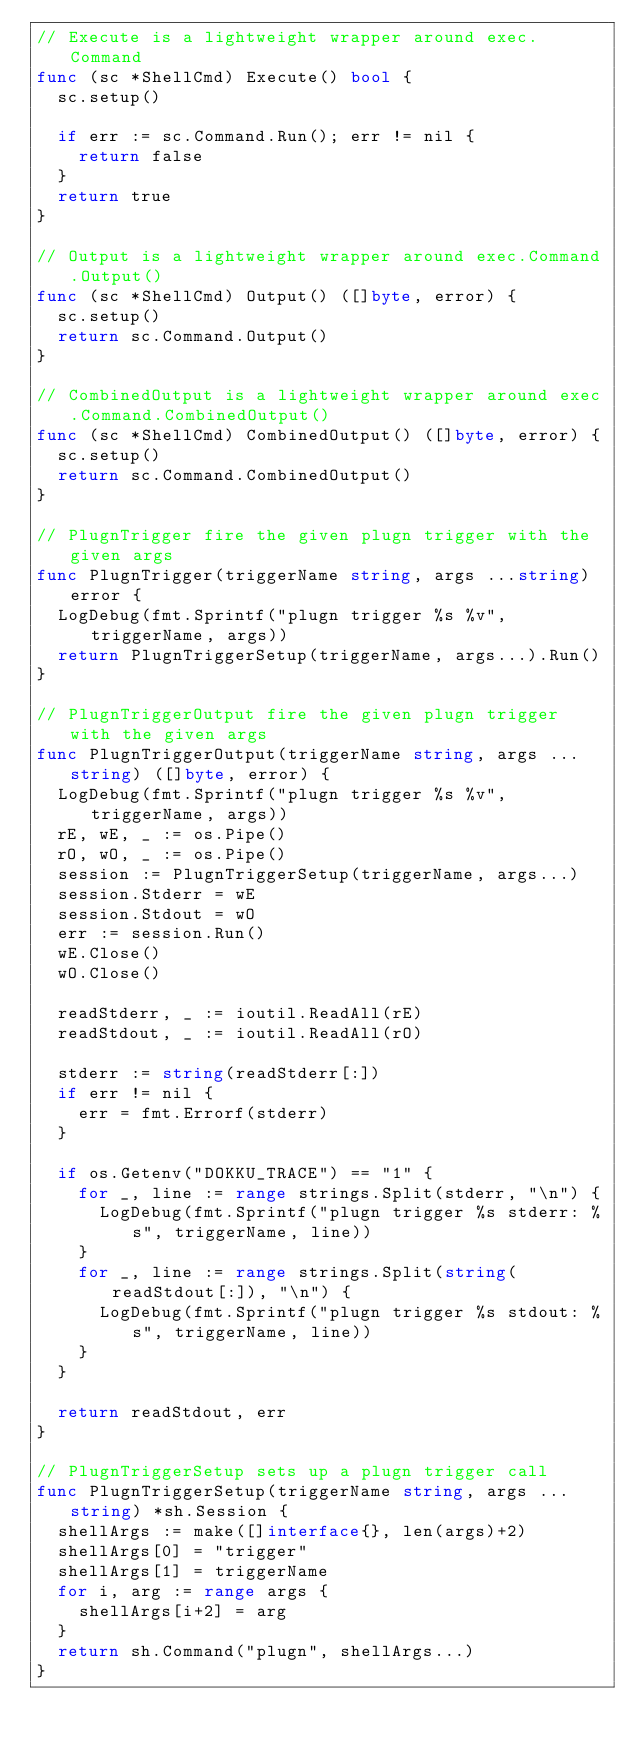Convert code to text. <code><loc_0><loc_0><loc_500><loc_500><_Go_>// Execute is a lightweight wrapper around exec.Command
func (sc *ShellCmd) Execute() bool {
	sc.setup()

	if err := sc.Command.Run(); err != nil {
		return false
	}
	return true
}

// Output is a lightweight wrapper around exec.Command.Output()
func (sc *ShellCmd) Output() ([]byte, error) {
	sc.setup()
	return sc.Command.Output()
}

// CombinedOutput is a lightweight wrapper around exec.Command.CombinedOutput()
func (sc *ShellCmd) CombinedOutput() ([]byte, error) {
	sc.setup()
	return sc.Command.CombinedOutput()
}

// PlugnTrigger fire the given plugn trigger with the given args
func PlugnTrigger(triggerName string, args ...string) error {
	LogDebug(fmt.Sprintf("plugn trigger %s %v", triggerName, args))
	return PlugnTriggerSetup(triggerName, args...).Run()
}

// PlugnTriggerOutput fire the given plugn trigger with the given args
func PlugnTriggerOutput(triggerName string, args ...string) ([]byte, error) {
	LogDebug(fmt.Sprintf("plugn trigger %s %v", triggerName, args))
	rE, wE, _ := os.Pipe()
	rO, wO, _ := os.Pipe()
	session := PlugnTriggerSetup(triggerName, args...)
	session.Stderr = wE
	session.Stdout = wO
	err := session.Run()
	wE.Close()
	wO.Close()

	readStderr, _ := ioutil.ReadAll(rE)
	readStdout, _ := ioutil.ReadAll(rO)

	stderr := string(readStderr[:])
	if err != nil {
		err = fmt.Errorf(stderr)
	}

	if os.Getenv("DOKKU_TRACE") == "1" {
		for _, line := range strings.Split(stderr, "\n") {
			LogDebug(fmt.Sprintf("plugn trigger %s stderr: %s", triggerName, line))
		}
		for _, line := range strings.Split(string(readStdout[:]), "\n") {
			LogDebug(fmt.Sprintf("plugn trigger %s stdout: %s", triggerName, line))
		}
	}

	return readStdout, err
}

// PlugnTriggerSetup sets up a plugn trigger call
func PlugnTriggerSetup(triggerName string, args ...string) *sh.Session {
	shellArgs := make([]interface{}, len(args)+2)
	shellArgs[0] = "trigger"
	shellArgs[1] = triggerName
	for i, arg := range args {
		shellArgs[i+2] = arg
	}
	return sh.Command("plugn", shellArgs...)
}
</code> 